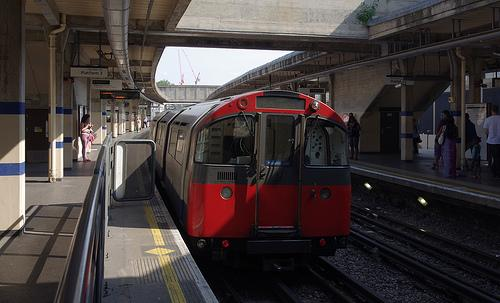What different colors can be seen in the image, and where are they located? Yellow paint and line on platform, white paint on platform, blue paint on pillar, blue stripes on posts, red paint on train, red and black train colors. Describe the position and appearance of the sign in the image. The sign is located above the woman on the platform, and it is hanging from the ceiling. What details can you provide about the train and its surroundings? The train is red and black, has a door, a mirror on its side, lights beside the door, and it's pulling into the station. Which objects can be found in the image, specifically related to the woman on the platform? There is a woman standing on the platform, a sign above her, and she is waiting for her train. Can you list the colors and locations of the paint on the platform and train? Yellow paint on the platform, white paint on the platform, red paint on the train, and blue paint on a pillar. List some objects that can be found in the sky area of the image. There is an open sky above the platform and silver tubing on the roof of the station. Mention any details about the train's door and surrounding elements. The train has a back door, a mirror on its side, and red lights beside the door. What are some things that can be seen on the platform's ground? Yellow line, shadows, diamond, pebbles between tracks, and railroad tracks on the ground. Identify the platform's features, such as colors and objects present. Yellow line and shadows on the platform, open sky above, blue stripes on the pillars, people waiting, and a sign hanging from the ceiling. What can you tell me about the railroad tracks and their environment? There are pebbles between the tracks, railroads in the ground, two lights beside them, and a yellow diamond on the ground. 